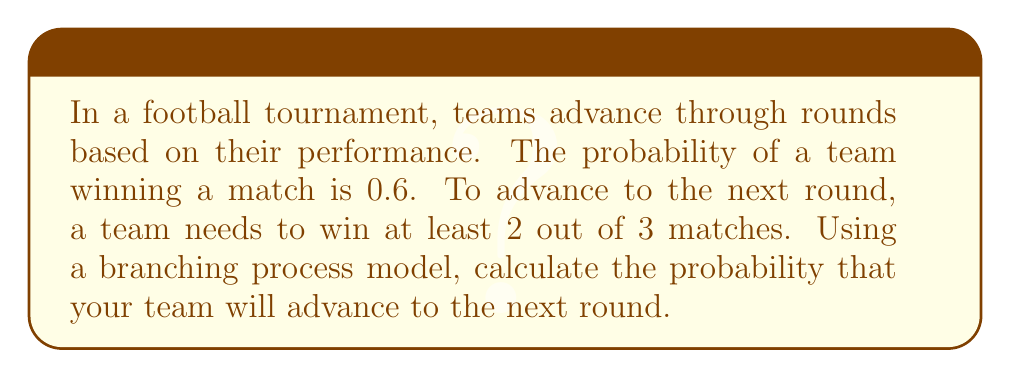Show me your answer to this math problem. Let's approach this step-by-step using a branching process model:

1) First, we need to identify the possible outcomes. A team can win 2 or 3 matches out of 3.

2) The probability of winning a single match is given as 0.6.

3) We can use the binomial probability formula to calculate the probability of each favorable outcome:

   P(X = k) = $\binom{n}{k}$ $p^k$ $(1-p)^{n-k}$

   Where n is the number of trials (3 matches), k is the number of successes, p is the probability of success in a single trial (0.6).

4) For winning exactly 2 matches:
   P(X = 2) = $\binom{3}{2}$ $(0.6)^2$ $(0.4)^1$ 
             = 3 * 0.36 * 0.4 = 0.432

5) For winning all 3 matches:
   P(X = 3) = $\binom{3}{3}$ $(0.6)^3$ $(0.4)^0$
             = 1 * 0.216 * 1 = 0.216

6) The total probability of advancing is the sum of these probabilities:
   P(advancing) = P(X = 2) + P(X = 3) = 0.432 + 0.216 = 0.648

Therefore, the probability of advancing to the next round is 0.648 or 64.8%.
Answer: 0.648 